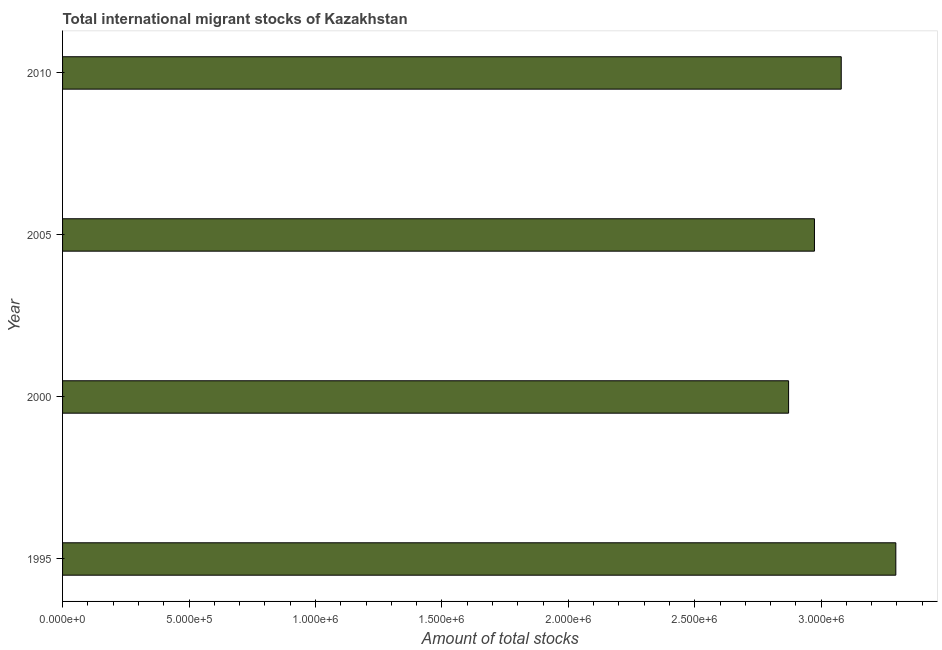Does the graph contain grids?
Make the answer very short. No. What is the title of the graph?
Provide a succinct answer. Total international migrant stocks of Kazakhstan. What is the label or title of the X-axis?
Your answer should be very brief. Amount of total stocks. What is the total number of international migrant stock in 2000?
Give a very brief answer. 2.87e+06. Across all years, what is the maximum total number of international migrant stock?
Keep it short and to the point. 3.30e+06. Across all years, what is the minimum total number of international migrant stock?
Keep it short and to the point. 2.87e+06. In which year was the total number of international migrant stock maximum?
Offer a terse response. 1995. In which year was the total number of international migrant stock minimum?
Make the answer very short. 2000. What is the sum of the total number of international migrant stock?
Provide a succinct answer. 1.22e+07. What is the difference between the total number of international migrant stock in 2000 and 2010?
Offer a very short reply. -2.08e+05. What is the average total number of international migrant stock per year?
Provide a short and direct response. 3.05e+06. What is the median total number of international migrant stock?
Ensure brevity in your answer.  3.03e+06. In how many years, is the total number of international migrant stock greater than 3000000 ?
Your answer should be compact. 2. What is the ratio of the total number of international migrant stock in 2000 to that in 2010?
Your response must be concise. 0.93. What is the difference between the highest and the second highest total number of international migrant stock?
Give a very brief answer. 2.16e+05. Is the sum of the total number of international migrant stock in 2005 and 2010 greater than the maximum total number of international migrant stock across all years?
Provide a succinct answer. Yes. What is the difference between the highest and the lowest total number of international migrant stock?
Your answer should be very brief. 4.24e+05. Are all the bars in the graph horizontal?
Provide a succinct answer. Yes. How many years are there in the graph?
Provide a succinct answer. 4. What is the Amount of total stocks of 1995?
Offer a very short reply. 3.30e+06. What is the Amount of total stocks of 2000?
Your response must be concise. 2.87e+06. What is the Amount of total stocks in 2005?
Ensure brevity in your answer.  2.97e+06. What is the Amount of total stocks of 2010?
Provide a succinct answer. 3.08e+06. What is the difference between the Amount of total stocks in 1995 and 2000?
Offer a terse response. 4.24e+05. What is the difference between the Amount of total stocks in 1995 and 2005?
Ensure brevity in your answer.  3.22e+05. What is the difference between the Amount of total stocks in 1995 and 2010?
Offer a terse response. 2.16e+05. What is the difference between the Amount of total stocks in 2000 and 2005?
Give a very brief answer. -1.02e+05. What is the difference between the Amount of total stocks in 2000 and 2010?
Provide a succinct answer. -2.08e+05. What is the difference between the Amount of total stocks in 2005 and 2010?
Keep it short and to the point. -1.06e+05. What is the ratio of the Amount of total stocks in 1995 to that in 2000?
Your answer should be very brief. 1.15. What is the ratio of the Amount of total stocks in 1995 to that in 2005?
Make the answer very short. 1.11. What is the ratio of the Amount of total stocks in 1995 to that in 2010?
Ensure brevity in your answer.  1.07. What is the ratio of the Amount of total stocks in 2000 to that in 2005?
Your answer should be very brief. 0.97. What is the ratio of the Amount of total stocks in 2000 to that in 2010?
Offer a very short reply. 0.93. What is the ratio of the Amount of total stocks in 2005 to that in 2010?
Offer a terse response. 0.97. 